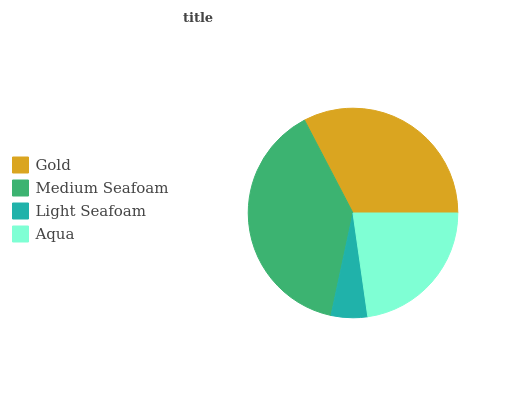Is Light Seafoam the minimum?
Answer yes or no. Yes. Is Medium Seafoam the maximum?
Answer yes or no. Yes. Is Medium Seafoam the minimum?
Answer yes or no. No. Is Light Seafoam the maximum?
Answer yes or no. No. Is Medium Seafoam greater than Light Seafoam?
Answer yes or no. Yes. Is Light Seafoam less than Medium Seafoam?
Answer yes or no. Yes. Is Light Seafoam greater than Medium Seafoam?
Answer yes or no. No. Is Medium Seafoam less than Light Seafoam?
Answer yes or no. No. Is Gold the high median?
Answer yes or no. Yes. Is Aqua the low median?
Answer yes or no. Yes. Is Light Seafoam the high median?
Answer yes or no. No. Is Medium Seafoam the low median?
Answer yes or no. No. 